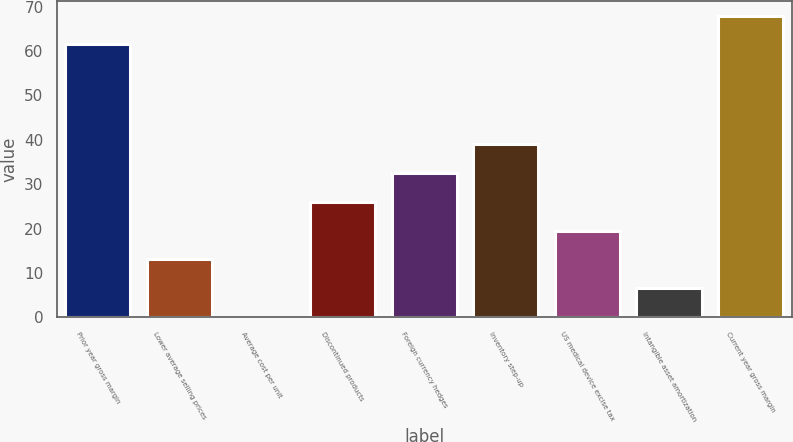Convert chart to OTSL. <chart><loc_0><loc_0><loc_500><loc_500><bar_chart><fcel>Prior year gross margin<fcel>Lower average selling prices<fcel>Average cost per unit<fcel>Discontinued products<fcel>Foreign currency hedges<fcel>Inventory step-up<fcel>US medical device excise tax<fcel>Intangible asset amortization<fcel>Current year gross margin<nl><fcel>61.5<fcel>13.06<fcel>0.1<fcel>26.02<fcel>32.5<fcel>38.98<fcel>19.54<fcel>6.58<fcel>67.98<nl></chart> 